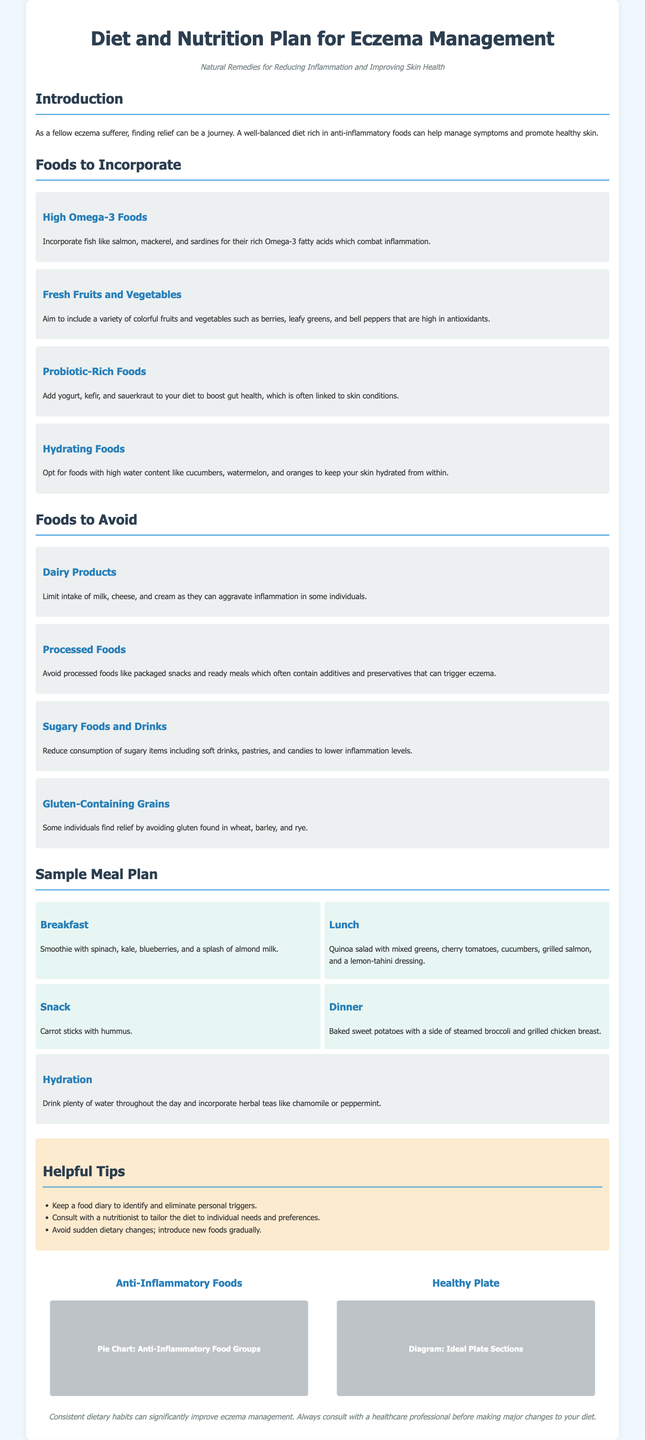what are the high Omega-3 foods suggested? The document specifies the inclusion of fish such as salmon, mackerel, and sardines for their high Omega-3 content.
Answer: salmon, mackerel, sardines what type of fruits and vegetables should be included? The document emphasizes incorporating a variety of colorful fruits and vegetables that are high in antioxidants.
Answer: colorful fruits and vegetables how many meals are included in the sample meal plan? The sample meal plan contains breakfast, lunch, snack, and dinner options, totaling four distinct meals.
Answer: four what type of drink is suggested for hydration? The document recommends drinking plenty of water and incorporating herbal teas for hydration.
Answer: water and herbal teas which food category is recommended to avoid? The document mentions dairy products as one of the food categories to limit or avoid.
Answer: dairy products what is the purpose of keeping a food diary? The helpful tips section suggests keeping a food diary to identify and eliminate personal triggers for eczema.
Answer: identify personal triggers what is the ideal hydration mentioned in the meal plan? The document suggests that one should drink plenty of water throughout the day as part of hydration.
Answer: plenty of water how is the anti-inflammatory food presented visually? The document features a pie chart representing different anti-inflammatory food groups.
Answer: pie chart who should be consulted for tailoring the diet? The document advises consulting with a nutritionist to customize dietary choices to individual needs.
Answer: nutritionist 